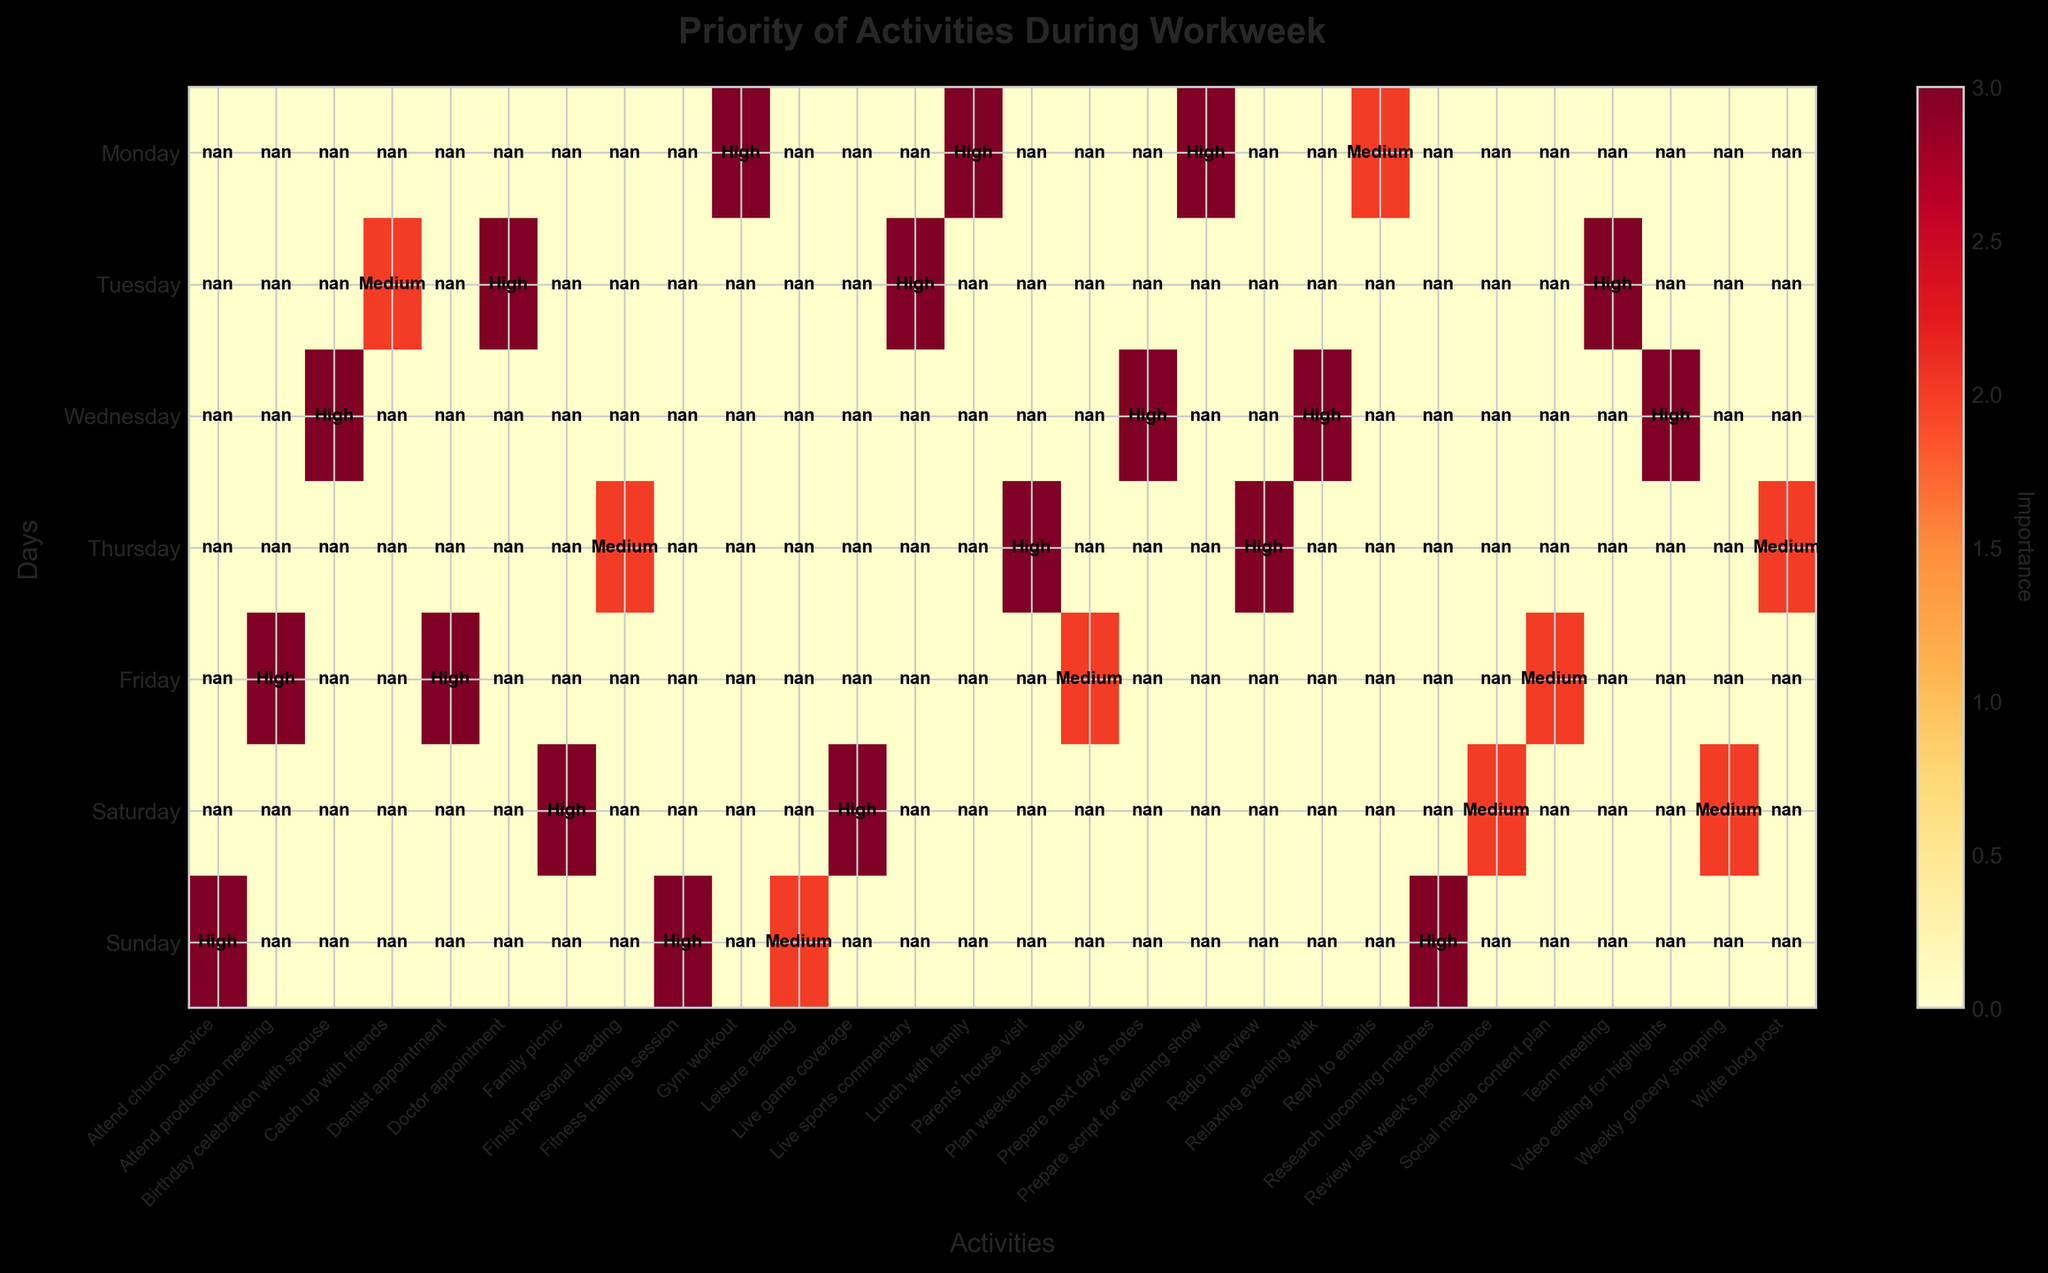What day has the most high-importance activities? By counting the high-importance activities depicted by the darkest color (usually red) for each day, we observe that Saturday has the highest number of high-importance activities.
Answer: Saturday Which day has the least medium-importance professional activities? Examining the heatmap for medium-importance professional activities (typically yellow or lighter), Sunday has none of these activities, so it has the least.
Answer: Sunday How many activities are there on Wednesday? Counting the number of distinct activities listed on the x-axis for Wednesday, we find there are four activities.
Answer: 4 Which activity on Friday has the highest importance? By observing Friday's activities, the dentist appointment has high importance indicated by the darkest color on the heatmap.
Answer: Dentist appointment Is there any personal activity of low importance on Thursday? Referring to the heatmap for Thursday, we see that 'Finish personal reading' has medium importance (typically yellow or lighter), indicating there is no personal activity of low importance.
Answer: No Which day has a higher number of low-importance activities, Monday or Sunday? Comparing the count of low-importance activities (typically the lightest color) between Monday (Lunch with family) and Sunday (Attend church service, Leisure reading), Sunday has more.
Answer: Sunday What are the high-importance activities on Tuesday? Observing the darkest colors on Tuesday, the high-importance activities are Live sports commentary, Doctor appointment, and Team meeting.
Answer: Live sports commentary, Doctor appointment, Team meeting Which type of activities dominates Wednesday in terms of importance? By checking how the colors are distributed for Wednesday, high-importance personal activities (Birthday celebration with spouse) dominate, as professional activities show medium importance.
Answer: Personal How often do professional activities appear per week compared to personal activities? Analyzing the x-axis labels and counting how many times professional activities appear versus personal activities, professional activities appear 13 times while personal activities appear 15 times.
Answer: Professional: 13, Personal: 15 